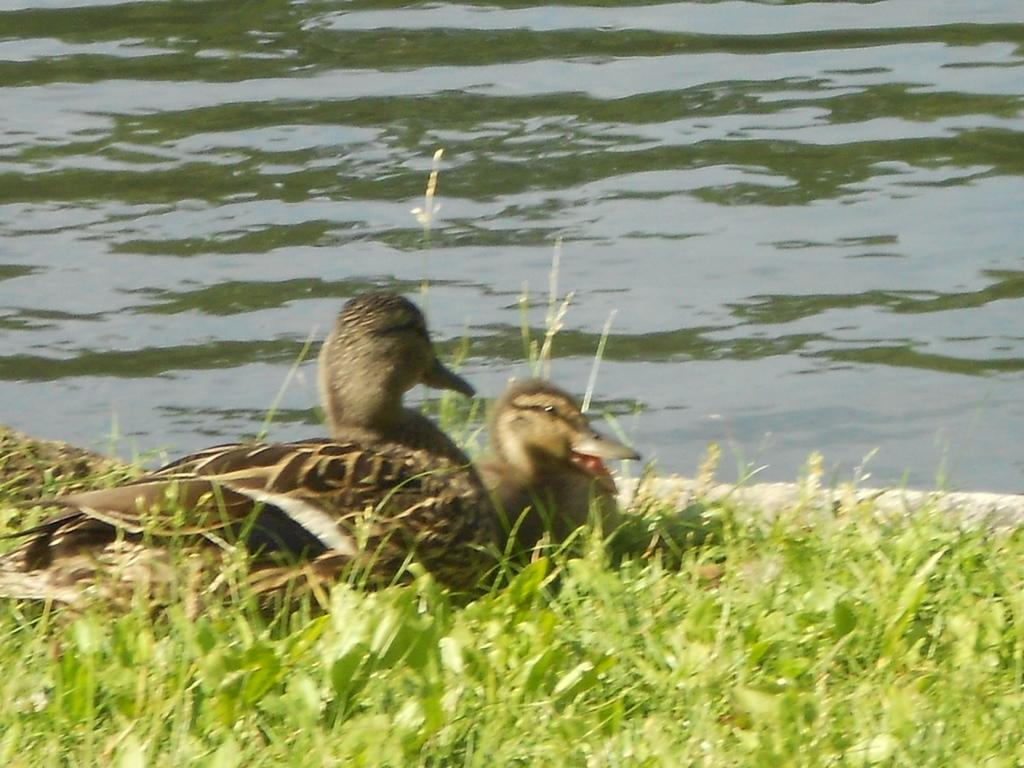How many ducks are in the image? There are two ducks in the image. What are the ducks doing in the image? The ducks are sitting on the grass. What is the body of water visible in the image? There is a lake with water visible in the image. What type of comparison can be made between the ducks and the tub in the image? There is no tub present in the image, so no comparison can be made between the ducks and a tub. 